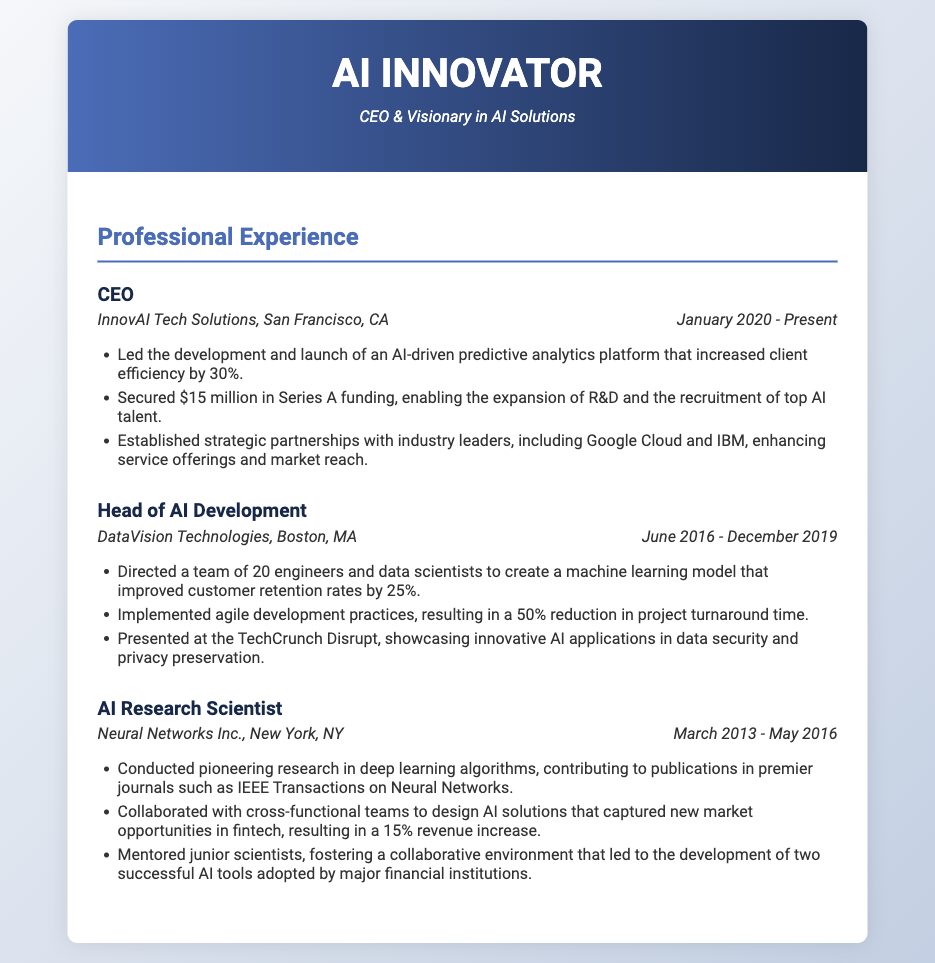What is the title of the current position? The document specifies the title of the current position held is "CEO."
Answer: CEO Where is InnovAI Tech Solutions located? The document states that InnovAI Tech Solutions is based in San Francisco, CA.
Answer: San Francisco, CA When did the individual start their role as CEO? The document indicates that the CEO role began in January 2020.
Answer: January 2020 How much funding was secured in Series A? The CV mentions that $15 million was secured in Series A funding.
Answer: $15 million What was the focus of the AI model developed at DataVision Technologies? The AI model aimed to improve customer retention rates by 25%.
Answer: Customer retention rates How many engineers and data scientists were directed by the Head of AI Development? The document states a team of 20 engineers and data scientists was directed.
Answer: 20 What significant reduction was achieved by implementing agile development practices? The document states there was a 50% reduction in project turnaround time.
Answer: 50% Which well-known event did the individual present at? The document indicates the individual presented at TechCrunch Disrupt.
Answer: TechCrunch Disrupt What is the individual's most recent achievement mentioned? The recent achievement is the launch of an AI-driven predictive analytics platform.
Answer: AI-driven predictive analytics platform 